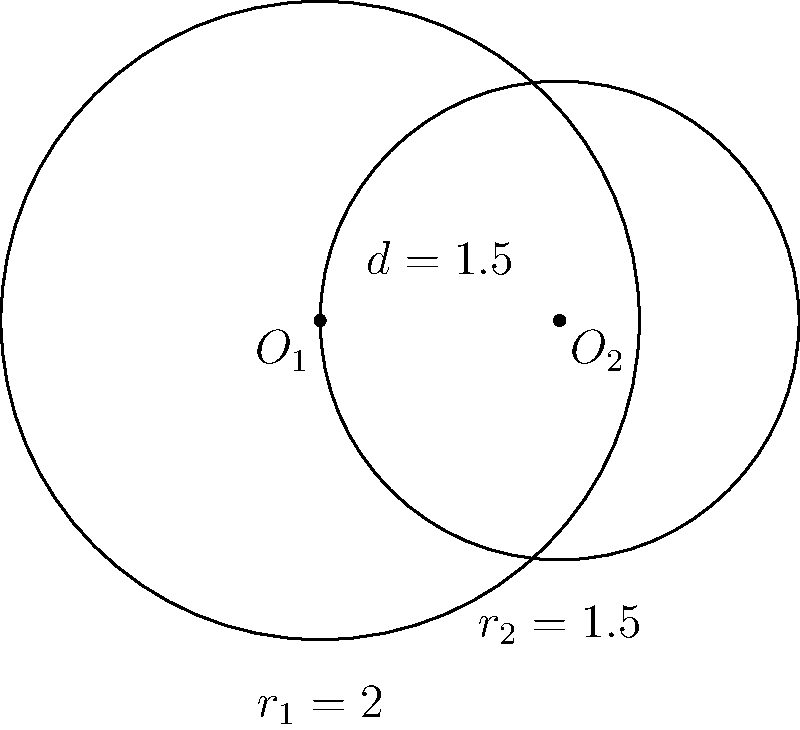Given two intersecting circles with centers $O_1$ and $O_2$, radii $r_1 = 2$ and $r_2 = 1.5$, and distance between centers $d = 1.5$, calculate the area of the region between the two circles. Round your answer to three decimal places. To solve this problem, we'll follow these steps:

1) First, we need to calculate the area of intersection between the two circles.

2) The area of intersection can be found using the formula:
   $$A = r_1^2 \arccos(\frac{d^2 + r_1^2 - r_2^2}{2dr_1}) + r_2^2 \arccos(\frac{d^2 + r_2^2 - r_1^2}{2dr_2}) - \frac{1}{2}\sqrt{(-d+r_1+r_2)(d+r_1-r_2)(d-r_1+r_2)(d+r_1+r_2)}$$

3) Substituting our values:
   $r_1 = 2$, $r_2 = 1.5$, $d = 1.5$

4) Calculating:
   $$A = 2^2 \arccos(\frac{1.5^2 + 2^2 - 1.5^2}{2 * 1.5 * 2}) + 1.5^2 \arccos(\frac{1.5^2 + 1.5^2 - 2^2}{2 * 1.5 * 1.5}) - \frac{1}{2}\sqrt{(-1.5+2+1.5)(1.5+2-1.5)(1.5-2+1.5)(1.5+2+1.5)}$$

5) This evaluates to approximately 1.284 square units.

6) Now, we need to calculate the areas of both circles:
   Circle 1: $A_1 = \pi r_1^2 = \pi * 2^2 = 4\pi$
   Circle 2: $A_2 = \pi r_2^2 = \pi * 1.5^2 = 2.25\pi$

7) The area between the circles is the sum of the areas minus twice the intersection area:
   $$A_{between} = A_1 + A_2 - 2A = 4\pi + 2.25\pi - 2 * 1.284$$

8) This evaluates to approximately 14.220 square units.
Answer: 14.220 square units 